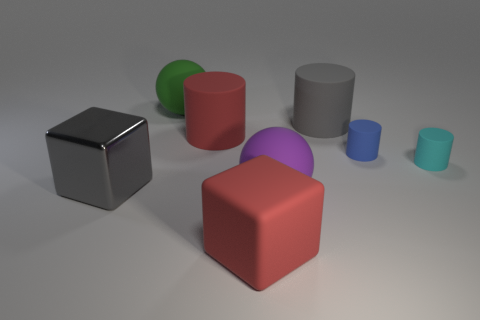Are there any other things that have the same material as the large gray cube?
Ensure brevity in your answer.  No. There is a big thing that is on the right side of the green ball and on the left side of the red matte block; what is its material?
Your answer should be compact. Rubber. What is the material of the large ball behind the cyan matte cylinder?
Offer a terse response. Rubber. Are there fewer gray shiny things than things?
Offer a very short reply. Yes. Do the cyan matte object and the large gray thing that is right of the big gray shiny block have the same shape?
Your answer should be compact. Yes. What shape is the thing that is left of the big red matte cylinder and right of the big metal thing?
Your answer should be compact. Sphere. Is the number of big green balls that are to the left of the large green ball the same as the number of gray shiny blocks on the left side of the big gray rubber thing?
Your answer should be compact. No. Is the shape of the red thing that is behind the small blue object the same as  the gray matte object?
Keep it short and to the point. Yes. How many red objects are small things or large metal things?
Your answer should be very brief. 0. There is a large thing that is behind the big gray rubber cylinder; what is its shape?
Offer a terse response. Sphere. 